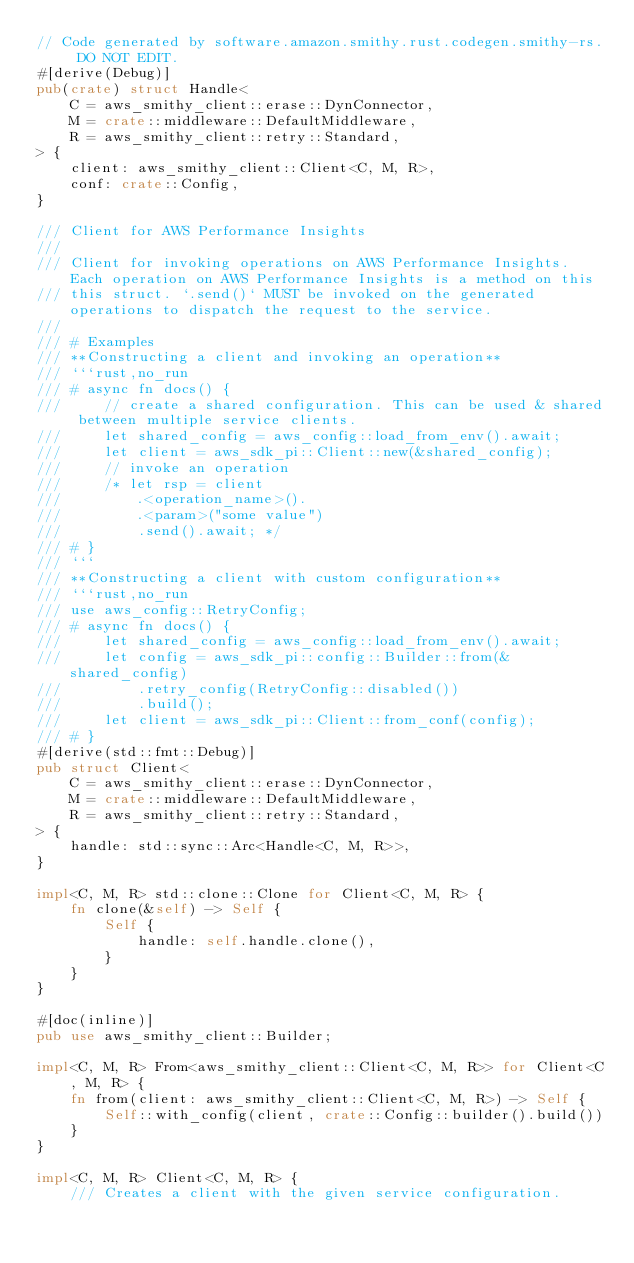Convert code to text. <code><loc_0><loc_0><loc_500><loc_500><_Rust_>// Code generated by software.amazon.smithy.rust.codegen.smithy-rs. DO NOT EDIT.
#[derive(Debug)]
pub(crate) struct Handle<
    C = aws_smithy_client::erase::DynConnector,
    M = crate::middleware::DefaultMiddleware,
    R = aws_smithy_client::retry::Standard,
> {
    client: aws_smithy_client::Client<C, M, R>,
    conf: crate::Config,
}

/// Client for AWS Performance Insights
///
/// Client for invoking operations on AWS Performance Insights. Each operation on AWS Performance Insights is a method on this
/// this struct. `.send()` MUST be invoked on the generated operations to dispatch the request to the service.
///
/// # Examples
/// **Constructing a client and invoking an operation**
/// ```rust,no_run
/// # async fn docs() {
///     // create a shared configuration. This can be used & shared between multiple service clients.
///     let shared_config = aws_config::load_from_env().await;
///     let client = aws_sdk_pi::Client::new(&shared_config);
///     // invoke an operation
///     /* let rsp = client
///         .<operation_name>().
///         .<param>("some value")
///         .send().await; */
/// # }
/// ```
/// **Constructing a client with custom configuration**
/// ```rust,no_run
/// use aws_config::RetryConfig;
/// # async fn docs() {
///     let shared_config = aws_config::load_from_env().await;
///     let config = aws_sdk_pi::config::Builder::from(&shared_config)
///         .retry_config(RetryConfig::disabled())
///         .build();
///     let client = aws_sdk_pi::Client::from_conf(config);
/// # }
#[derive(std::fmt::Debug)]
pub struct Client<
    C = aws_smithy_client::erase::DynConnector,
    M = crate::middleware::DefaultMiddleware,
    R = aws_smithy_client::retry::Standard,
> {
    handle: std::sync::Arc<Handle<C, M, R>>,
}

impl<C, M, R> std::clone::Clone for Client<C, M, R> {
    fn clone(&self) -> Self {
        Self {
            handle: self.handle.clone(),
        }
    }
}

#[doc(inline)]
pub use aws_smithy_client::Builder;

impl<C, M, R> From<aws_smithy_client::Client<C, M, R>> for Client<C, M, R> {
    fn from(client: aws_smithy_client::Client<C, M, R>) -> Self {
        Self::with_config(client, crate::Config::builder().build())
    }
}

impl<C, M, R> Client<C, M, R> {
    /// Creates a client with the given service configuration.</code> 